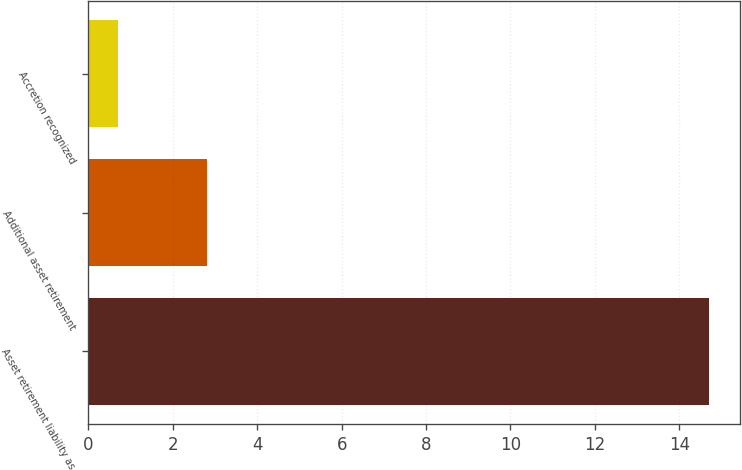Convert chart to OTSL. <chart><loc_0><loc_0><loc_500><loc_500><bar_chart><fcel>Asset retirement liability as<fcel>Additional asset retirement<fcel>Accretion recognized<nl><fcel>14.7<fcel>2.8<fcel>0.7<nl></chart> 